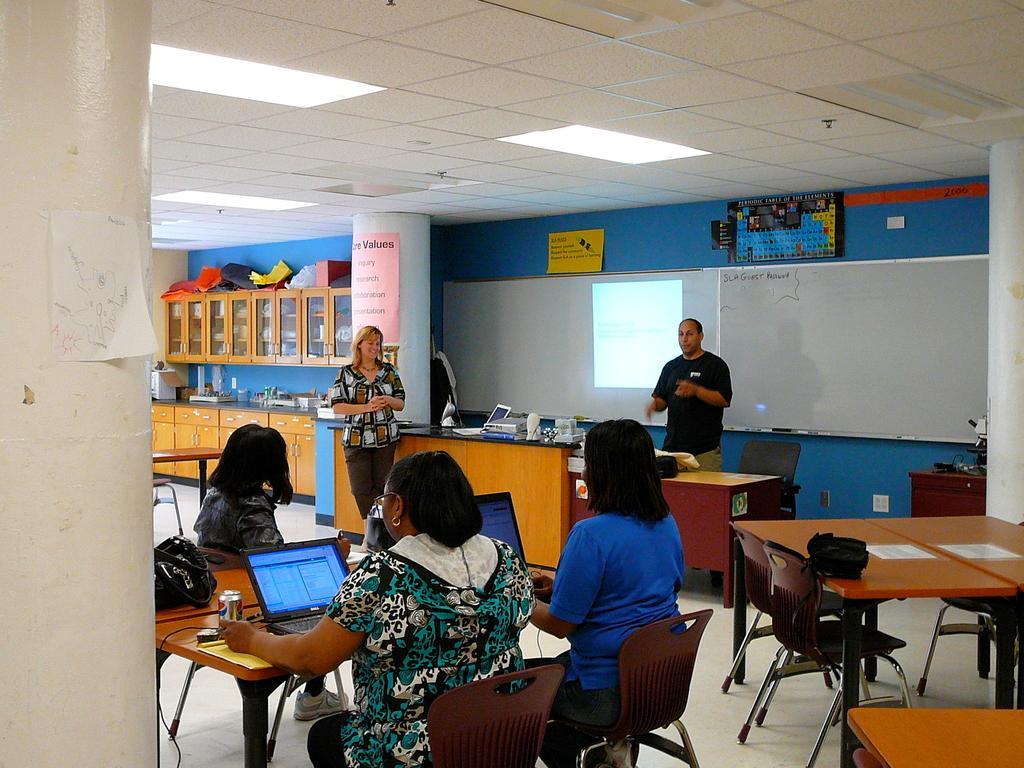How would you summarize this image in a sentence or two? In this picture there are three women sitting on the chair. There is a laptop, handbag, coke tin , wire on the table. There are menu cards on the table. There is a man and a woman standing. There are few objects and laptop on the desk. There are some items in the cupboard There is a poster on the wall. There are lights. 